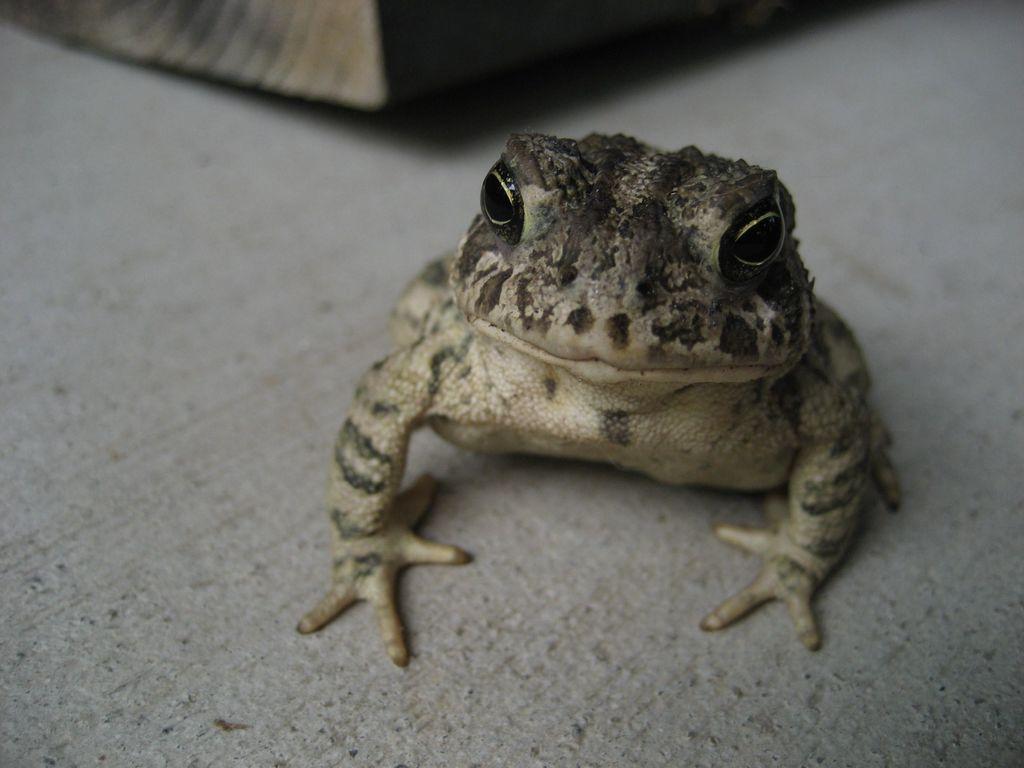Describe this image in one or two sentences. In this image, we can see a frog on the surface. Top of the image, there is a blur view. Here we can see some object. 